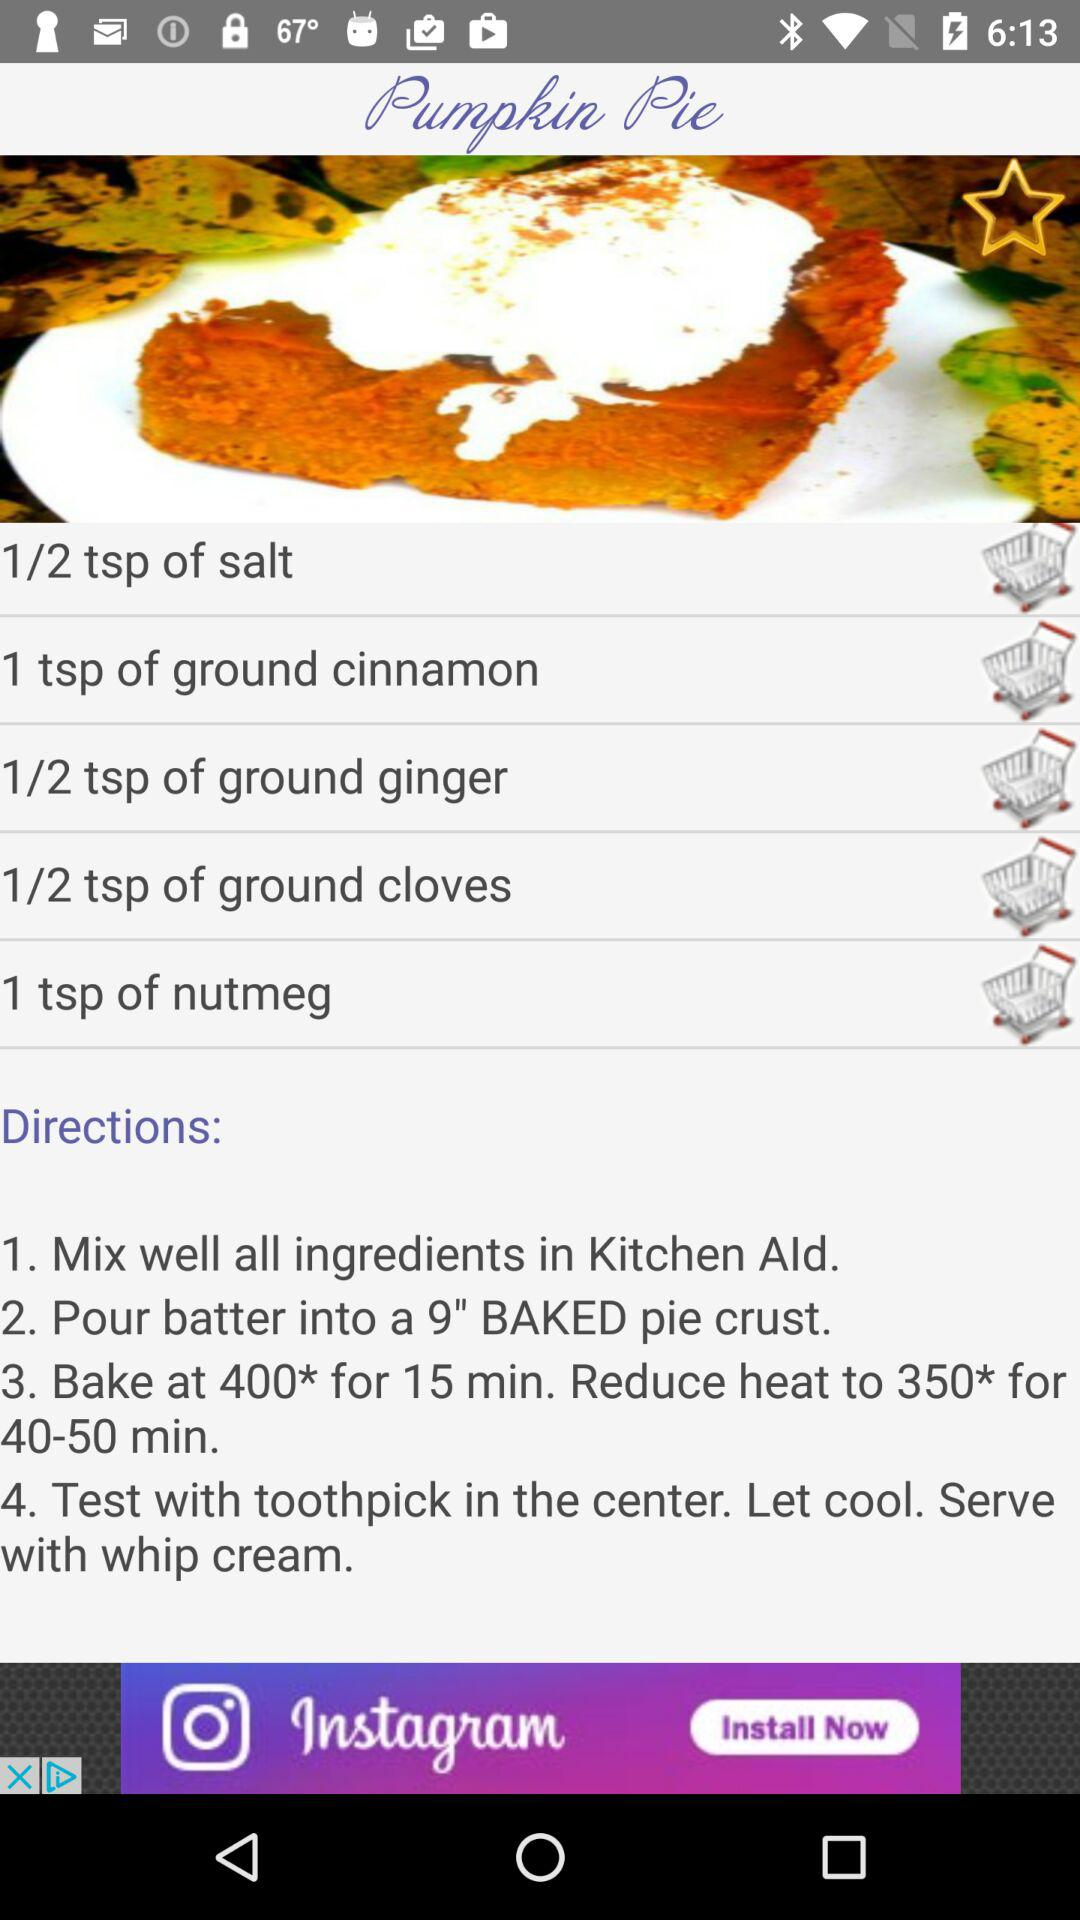What is the name of the dish? The name of the dish is "Pumpkin Pie". 